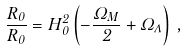Convert formula to latex. <formula><loc_0><loc_0><loc_500><loc_500>\frac { \ddot { R } _ { 0 } } { R _ { 0 } } = H _ { 0 } ^ { 2 } \left ( - \frac { \Omega _ { M } } { 2 } + \Omega _ { \Lambda } \right ) \, ,</formula> 